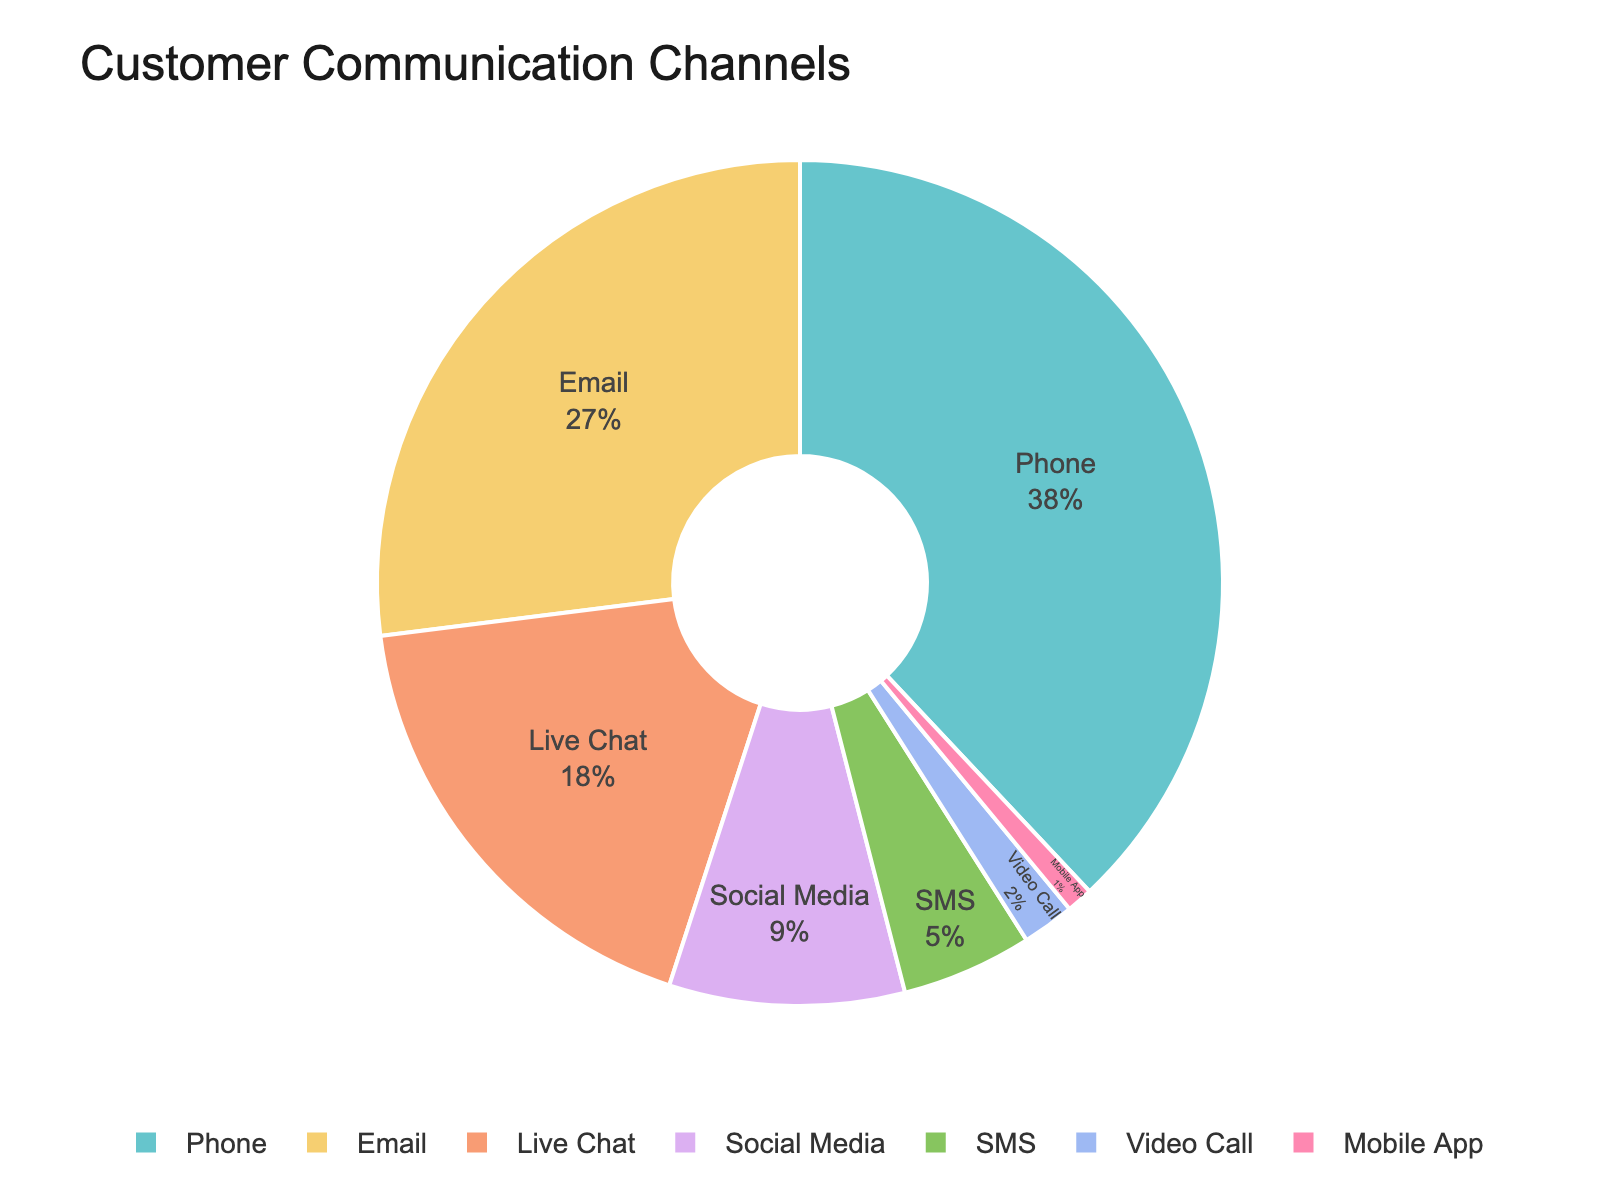Which communication channel has the highest percentage of customer use? The pie chart visually indicates that 'Phone' is the largest segment of the chart. The label on this segment shows 38%, which is the highest percentage compared to the others.
Answer: Phone What is the combined percentage for Email and Live Chat? From the figure, the percentage for 'Email' is 27% and 'Live Chat' is 18%. Adding these together gives 27% + 18% = 45%.
Answer: 45% Which communication channel is used more, Social Media or SMS? In the pie chart, 'Social Media' has a segment showing 9%, while 'SMS' is represented with 5%. Since 9% > 5%, Social Media is used more.
Answer: Social Media How much larger is the percentage of Phone users compared to Video Call users? The percentage for 'Phone' is 38%, and for 'Video Call' it is 2%. The difference is found by subtracting the smaller percentage from the larger one: 38% - 2% = 36%.
Answer: 36% List the communication channels in descending order of usage percentage. The segments of the pie chart, from largest to smallest, indicate the following order: Phone (38%), Email (27%), Live Chat (18%), Social Media (9%), SMS (5%), Video Call (2%), and Mobile App (1%).
Answer: Phone, Email, Live Chat, Social Media, SMS, Video Call, Mobile App What percentage of customers do not use either Phone or Email? Combined, Phone and Email usage is 38% + 27% = 65%. Therefore, the percentage of customers using other channels is 100% - 65% = 35%.
Answer: 35% Is the use of Live Chat greater than the combined use of Video Call and Mobile App? From the pie chart, Live Chat has 18%. The combined usage of Video Call (2%) and Mobile App (1%) amounts to 2% + 1% = 3%. Since 18% > 3%, Live Chat is indeed used more.
Answer: Yes Compare the usage frequency of Social Media and Mobile App. How many times more is Social Media used? The percentage for Social Media is 9%, and for Mobile App, it's 1%. To find how many times more Social Media is used, divide the former by the latter: 9% / 1% = 9 times.
Answer: 9 times 